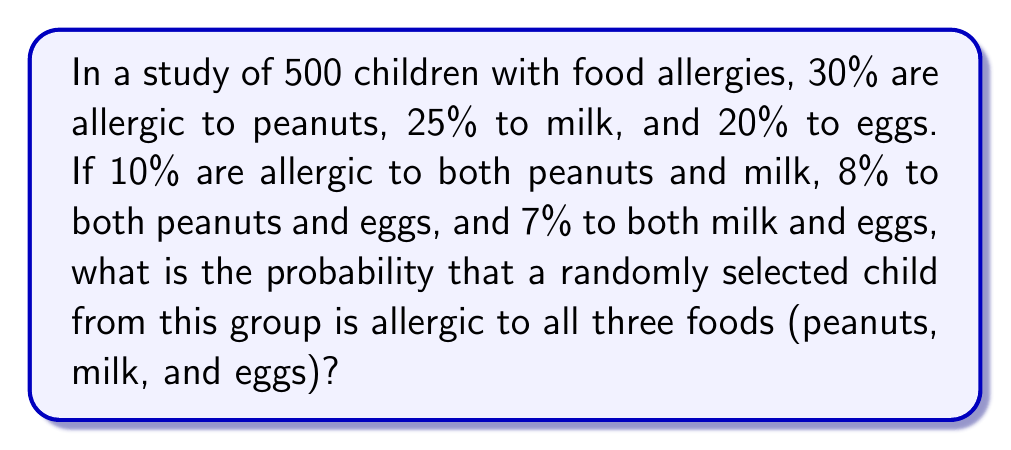Show me your answer to this math problem. Let's approach this step-by-step using set theory and the inclusion-exclusion principle:

1) Let P = peanut allergy, M = milk allergy, E = egg allergy

2) Given:
   $P(P) = 0.30$, $P(M) = 0.25$, $P(E) = 0.20$
   $P(P \cap M) = 0.10$, $P(P \cap E) = 0.08$, $P(M \cap E) = 0.07$

3) We need to find $P(P \cap M \cap E)$

4) The inclusion-exclusion principle for three sets states:

   $P(P \cup M \cup E) = P(P) + P(M) + P(E) - P(P \cap M) - P(P \cap E) - P(M \cap E) + P(P \cap M \cap E)$

5) We can rearrange this to solve for $P(P \cap M \cap E)$:

   $P(P \cap M \cap E) = P(P) + P(M) + P(E) - P(P \cap M) - P(P \cap E) - P(M \cap E) - P(P \cup M \cup E)$

6) We know all terms except $P(P \cup M \cup E)$. However, this represents the probability of being allergic to at least one of the three foods, which must be less than or equal to 1.

7) Let's calculate the maximum possible value for $P(P \cap M \cap E)$:

   $P(P \cap M \cap E) = 0.30 + 0.25 + 0.20 - 0.10 - 0.08 - 0.07 - 1$
                       $= 0.75 - 0.25 - 1$
                       $= -0.50$

8) Since probabilities cannot be negative, the actual probability must be greater than this. The closest valid probability is 0.

Therefore, the probability that a randomly selected child is allergic to all three foods is 0 or very close to 0.
Answer: 0 